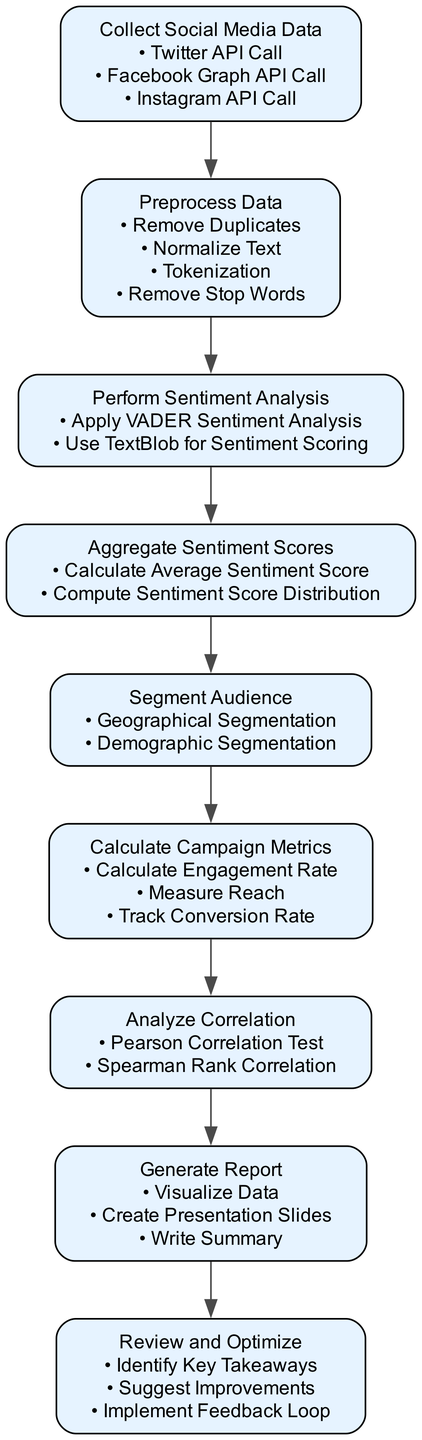What is the first step in the flowchart? The first step in the flowchart is "Collect Social Media Data," which is indicated as the first node in the diagram.
Answer: Collect Social Media Data How many actions are listed under "Preprocess Data"? Under the "Preprocess Data" node, there are four actions listed: "Remove Duplicates," "Normalize Text," "Tokenization," and "Remove Stop Words."
Answer: Four What comes after "Aggregate Sentiment Scores"? After "Aggregate Sentiment Scores," the next node in the flowchart is "Segment Audience." The edges in the diagram illustrate this flow sequence.
Answer: Segment Audience Identify the last step in the flowchart. The last step in the flowchart is "Review and Optimize," as it is the final node connected by an edge from the previous node.
Answer: Review and Optimize What are the two methods used for sentiment analysis? The two methods mentioned for sentiment analysis are "VADER Sentiment Analysis" and "TextBlob for Sentiment Scoring," which are shown as actions under the "Perform Sentiment Analysis" node.
Answer: VADER Sentiment Analysis and TextBlob for Sentiment Scoring How many nodes are in the diagram? The diagram contains nine nodes, as each of the main steps in the process is represented as a distinct node.
Answer: Nine Which node involves analyzing relationships between sentiment and success? The node that involves analyzing relationships between sentiment and campaign success is "Analyze Correlation," which is connected to the previous steps regarding sentiment scoring and campaign metrics.
Answer: Analyze Correlation How many segments does "Segment Audience" divide based on? "Segment Audience" divides the audience into two segments: geographical and demographic, as indicated in the actions listed under that node.
Answer: Two What action is taken after calculating campaign metrics? After calculating campaign metrics, the next action taken is "Analyze Correlation," which examines the relationship between the metrics and sentiment analysis outcomes.
Answer: Analyze Correlation 